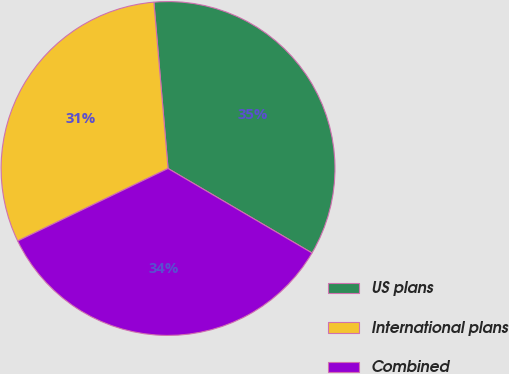Convert chart. <chart><loc_0><loc_0><loc_500><loc_500><pie_chart><fcel>US plans<fcel>International plans<fcel>Combined<nl><fcel>34.8%<fcel>30.8%<fcel>34.4%<nl></chart> 